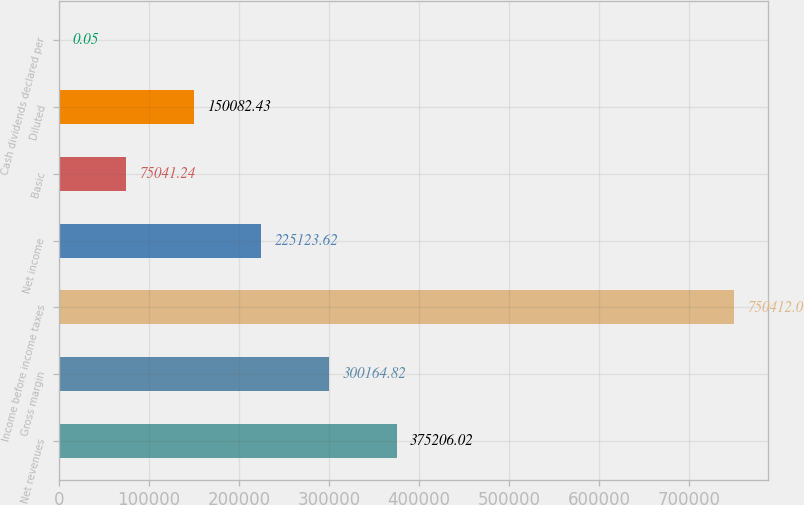<chart> <loc_0><loc_0><loc_500><loc_500><bar_chart><fcel>Net revenues<fcel>Gross margin<fcel>Income before income taxes<fcel>Net income<fcel>Basic<fcel>Diluted<fcel>Cash dividends declared per<nl><fcel>375206<fcel>300165<fcel>750412<fcel>225124<fcel>75041.2<fcel>150082<fcel>0.05<nl></chart> 